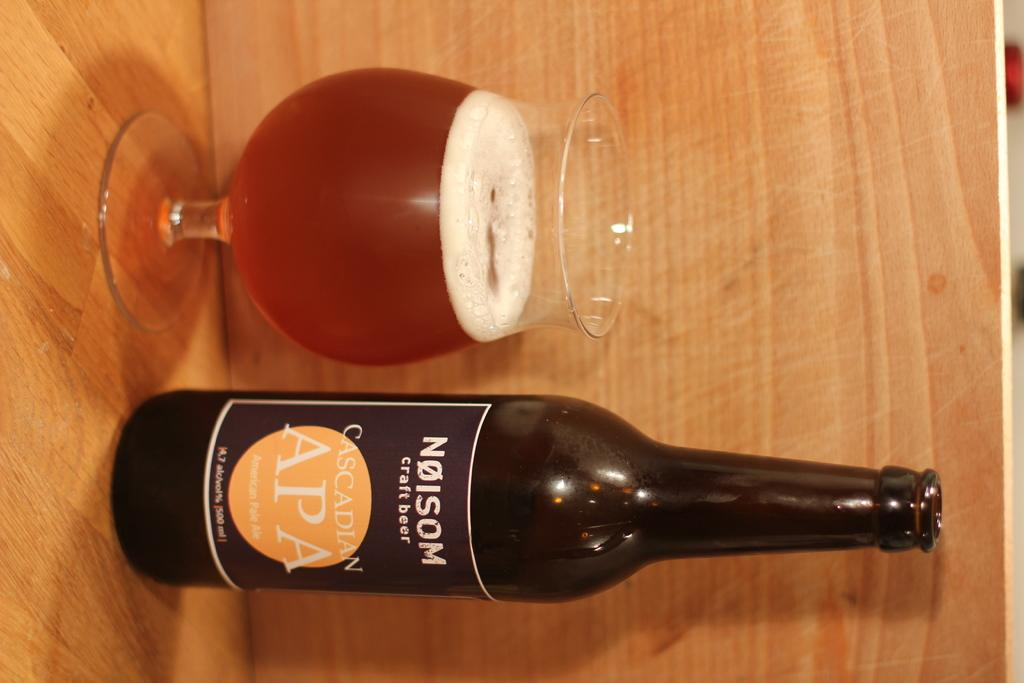Provide a one-sentence caption for the provided image. a bottle of beer with the word Nolsom on it next to a glass of same. 